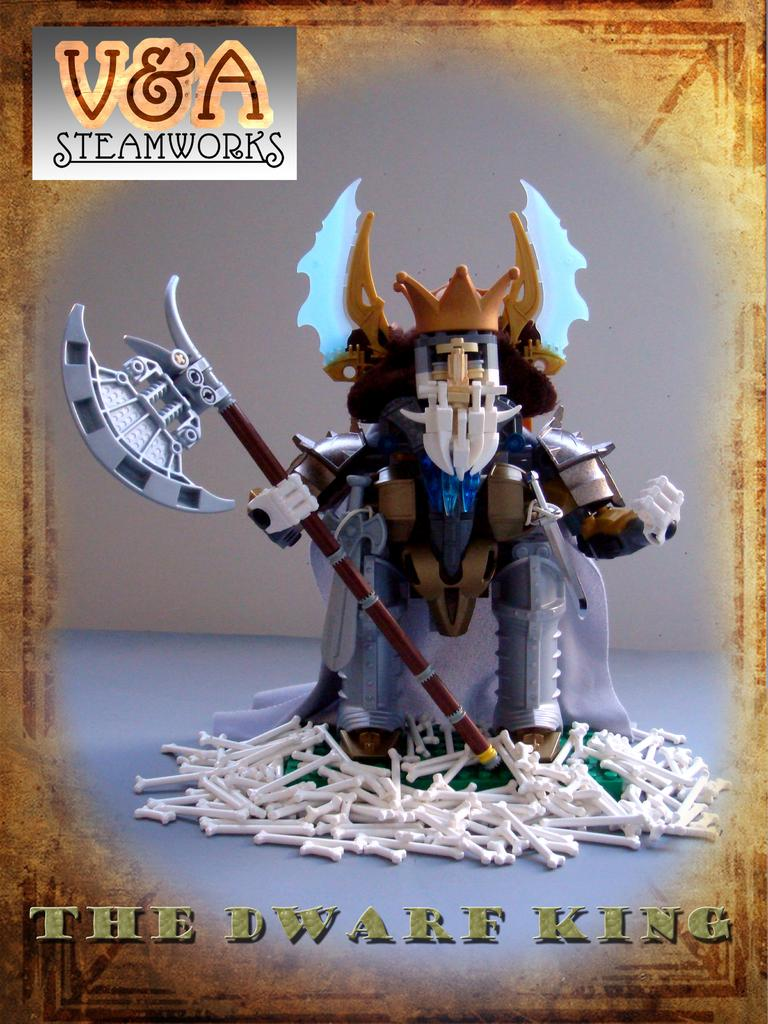What type of visual medium is the image? The image is a poster. What is the main subject of the poster? There is a toy holding a sword on the poster. What other elements are present on the poster besides the toy? There are bones depicted on the poster. Is there any text on the poster? Yes, there is text written on the poster. How does the poster contribute to the wealth of the viewer? The poster does not contribute to the wealth of the viewer, as it is a visual medium and not a financial asset. What type of spark can be seen emanating from the toy on the poster? There is no spark present on the poster; it only features a toy holding a sword, bones, and text. 